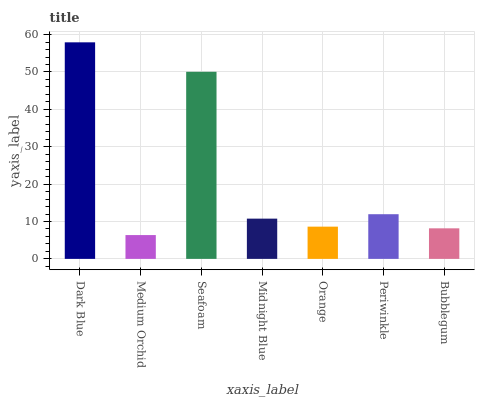Is Medium Orchid the minimum?
Answer yes or no. Yes. Is Dark Blue the maximum?
Answer yes or no. Yes. Is Seafoam the minimum?
Answer yes or no. No. Is Seafoam the maximum?
Answer yes or no. No. Is Seafoam greater than Medium Orchid?
Answer yes or no. Yes. Is Medium Orchid less than Seafoam?
Answer yes or no. Yes. Is Medium Orchid greater than Seafoam?
Answer yes or no. No. Is Seafoam less than Medium Orchid?
Answer yes or no. No. Is Midnight Blue the high median?
Answer yes or no. Yes. Is Midnight Blue the low median?
Answer yes or no. Yes. Is Seafoam the high median?
Answer yes or no. No. Is Seafoam the low median?
Answer yes or no. No. 